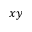Convert formula to latex. <formula><loc_0><loc_0><loc_500><loc_500>x y</formula> 